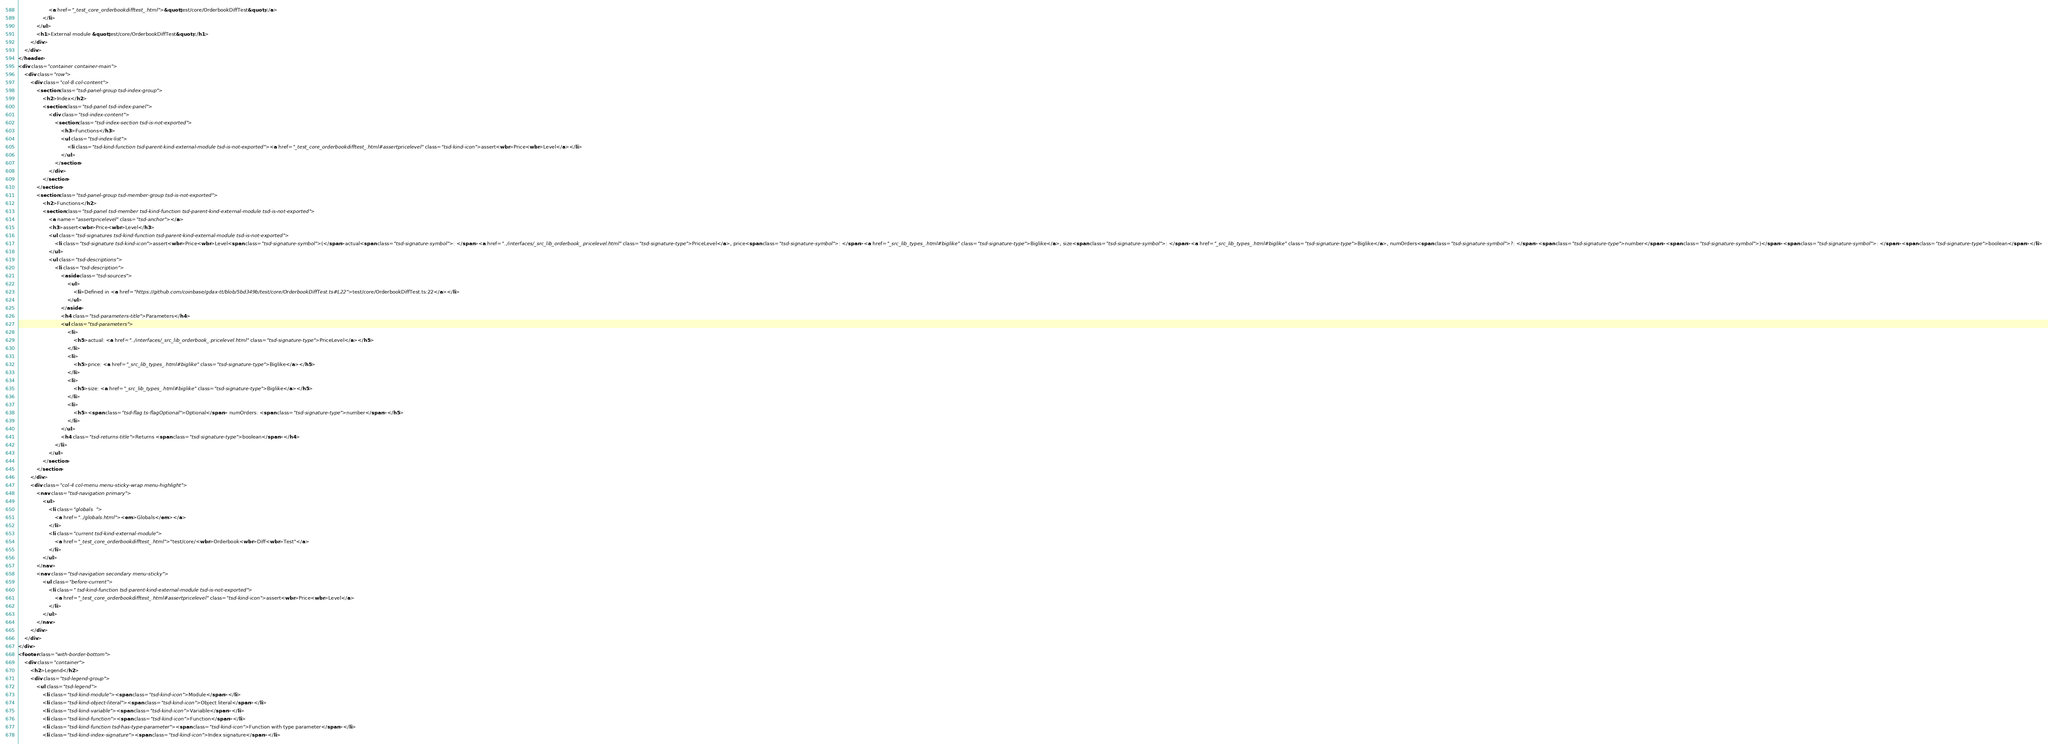Convert code to text. <code><loc_0><loc_0><loc_500><loc_500><_HTML_>					<a href="_test_core_orderbookdifftest_.html">&quot;test/core/OrderbookDiffTest&quot;</a>
				</li>
			</ul>
			<h1>External module &quot;test/core/OrderbookDiffTest&quot;</h1>
		</div>
	</div>
</header>
<div class="container container-main">
	<div class="row">
		<div class="col-8 col-content">
			<section class="tsd-panel-group tsd-index-group">
				<h2>Index</h2>
				<section class="tsd-panel tsd-index-panel">
					<div class="tsd-index-content">
						<section class="tsd-index-section tsd-is-not-exported">
							<h3>Functions</h3>
							<ul class="tsd-index-list">
								<li class="tsd-kind-function tsd-parent-kind-external-module tsd-is-not-exported"><a href="_test_core_orderbookdifftest_.html#assertpricelevel" class="tsd-kind-icon">assert<wbr>Price<wbr>Level</a></li>
							</ul>
						</section>
					</div>
				</section>
			</section>
			<section class="tsd-panel-group tsd-member-group tsd-is-not-exported">
				<h2>Functions</h2>
				<section class="tsd-panel tsd-member tsd-kind-function tsd-parent-kind-external-module tsd-is-not-exported">
					<a name="assertpricelevel" class="tsd-anchor"></a>
					<h3>assert<wbr>Price<wbr>Level</h3>
					<ul class="tsd-signatures tsd-kind-function tsd-parent-kind-external-module tsd-is-not-exported">
						<li class="tsd-signature tsd-kind-icon">assert<wbr>Price<wbr>Level<span class="tsd-signature-symbol">(</span>actual<span class="tsd-signature-symbol">: </span><a href="../interfaces/_src_lib_orderbook_.pricelevel.html" class="tsd-signature-type">PriceLevel</a>, price<span class="tsd-signature-symbol">: </span><a href="_src_lib_types_.html#biglike" class="tsd-signature-type">Biglike</a>, size<span class="tsd-signature-symbol">: </span><a href="_src_lib_types_.html#biglike" class="tsd-signature-type">Biglike</a>, numOrders<span class="tsd-signature-symbol">?: </span><span class="tsd-signature-type">number</span><span class="tsd-signature-symbol">)</span><span class="tsd-signature-symbol">: </span><span class="tsd-signature-type">boolean</span></li>
					</ul>
					<ul class="tsd-descriptions">
						<li class="tsd-description">
							<aside class="tsd-sources">
								<ul>
									<li>Defined in <a href="https://github.com/coinbase/gdax-tt/blob/5bd349b/test/core/OrderbookDiffTest.ts#L22">test/core/OrderbookDiffTest.ts:22</a></li>
								</ul>
							</aside>
							<h4 class="tsd-parameters-title">Parameters</h4>
							<ul class="tsd-parameters">
								<li>
									<h5>actual: <a href="../interfaces/_src_lib_orderbook_.pricelevel.html" class="tsd-signature-type">PriceLevel</a></h5>
								</li>
								<li>
									<h5>price: <a href="_src_lib_types_.html#biglike" class="tsd-signature-type">Biglike</a></h5>
								</li>
								<li>
									<h5>size: <a href="_src_lib_types_.html#biglike" class="tsd-signature-type">Biglike</a></h5>
								</li>
								<li>
									<h5><span class="tsd-flag ts-flagOptional">Optional</span> numOrders: <span class="tsd-signature-type">number</span></h5>
								</li>
							</ul>
							<h4 class="tsd-returns-title">Returns <span class="tsd-signature-type">boolean</span></h4>
						</li>
					</ul>
				</section>
			</section>
		</div>
		<div class="col-4 col-menu menu-sticky-wrap menu-highlight">
			<nav class="tsd-navigation primary">
				<ul>
					<li class="globals  ">
						<a href="../globals.html"><em>Globals</em></a>
					</li>
					<li class="current tsd-kind-external-module">
						<a href="_test_core_orderbookdifftest_.html">"test/core/<wbr>Orderbook<wbr>Diff<wbr>Test"</a>
					</li>
				</ul>
			</nav>
			<nav class="tsd-navigation secondary menu-sticky">
				<ul class="before-current">
					<li class=" tsd-kind-function tsd-parent-kind-external-module tsd-is-not-exported">
						<a href="_test_core_orderbookdifftest_.html#assertpricelevel" class="tsd-kind-icon">assert<wbr>Price<wbr>Level</a>
					</li>
				</ul>
			</nav>
		</div>
	</div>
</div>
<footer class="with-border-bottom">
	<div class="container">
		<h2>Legend</h2>
		<div class="tsd-legend-group">
			<ul class="tsd-legend">
				<li class="tsd-kind-module"><span class="tsd-kind-icon">Module</span></li>
				<li class="tsd-kind-object-literal"><span class="tsd-kind-icon">Object literal</span></li>
				<li class="tsd-kind-variable"><span class="tsd-kind-icon">Variable</span></li>
				<li class="tsd-kind-function"><span class="tsd-kind-icon">Function</span></li>
				<li class="tsd-kind-function tsd-has-type-parameter"><span class="tsd-kind-icon">Function with type parameter</span></li>
				<li class="tsd-kind-index-signature"><span class="tsd-kind-icon">Index signature</span></li></code> 